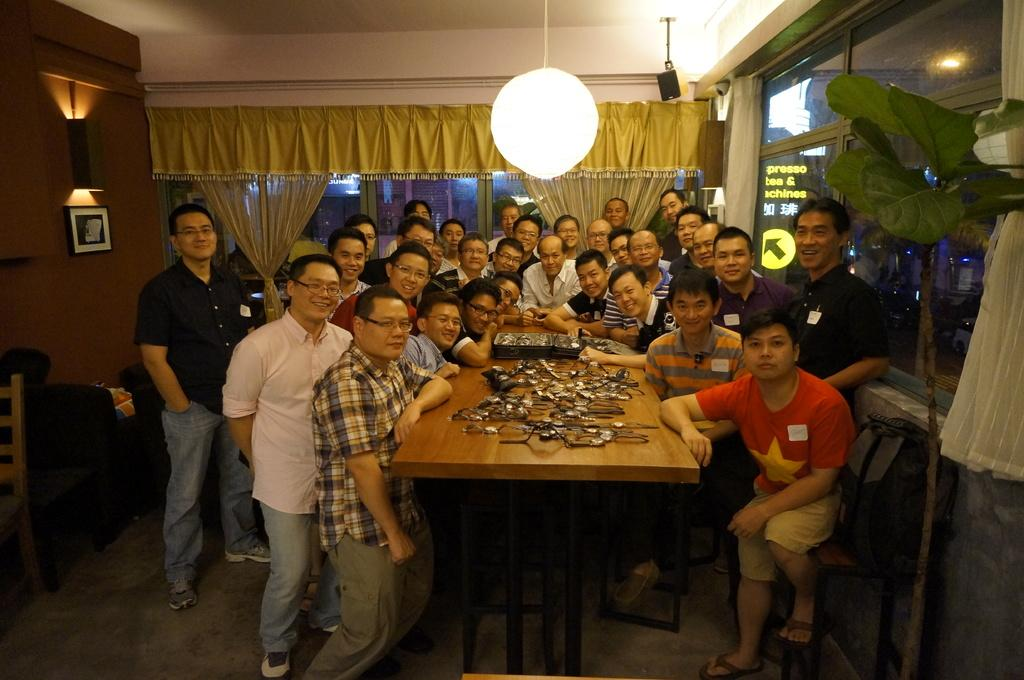How many people are in the image? There is a group of people in the image. What are the people in the image doing? Some people are standing, while others are sitting on chairs. What is on the table in the image? Spectacles are present on the table. What can be used for illumination in the image? There is a light in the image. What type of window treatment is visible in the image? Curtains are visible in the image. What type of plant is in the image? There is a plant in the image. What type of cast can be seen on the lawyer's leg in the image? There is no lawyer or cast present in the image. What type of tramp is visible in the image? There is no tramp present in the image. 